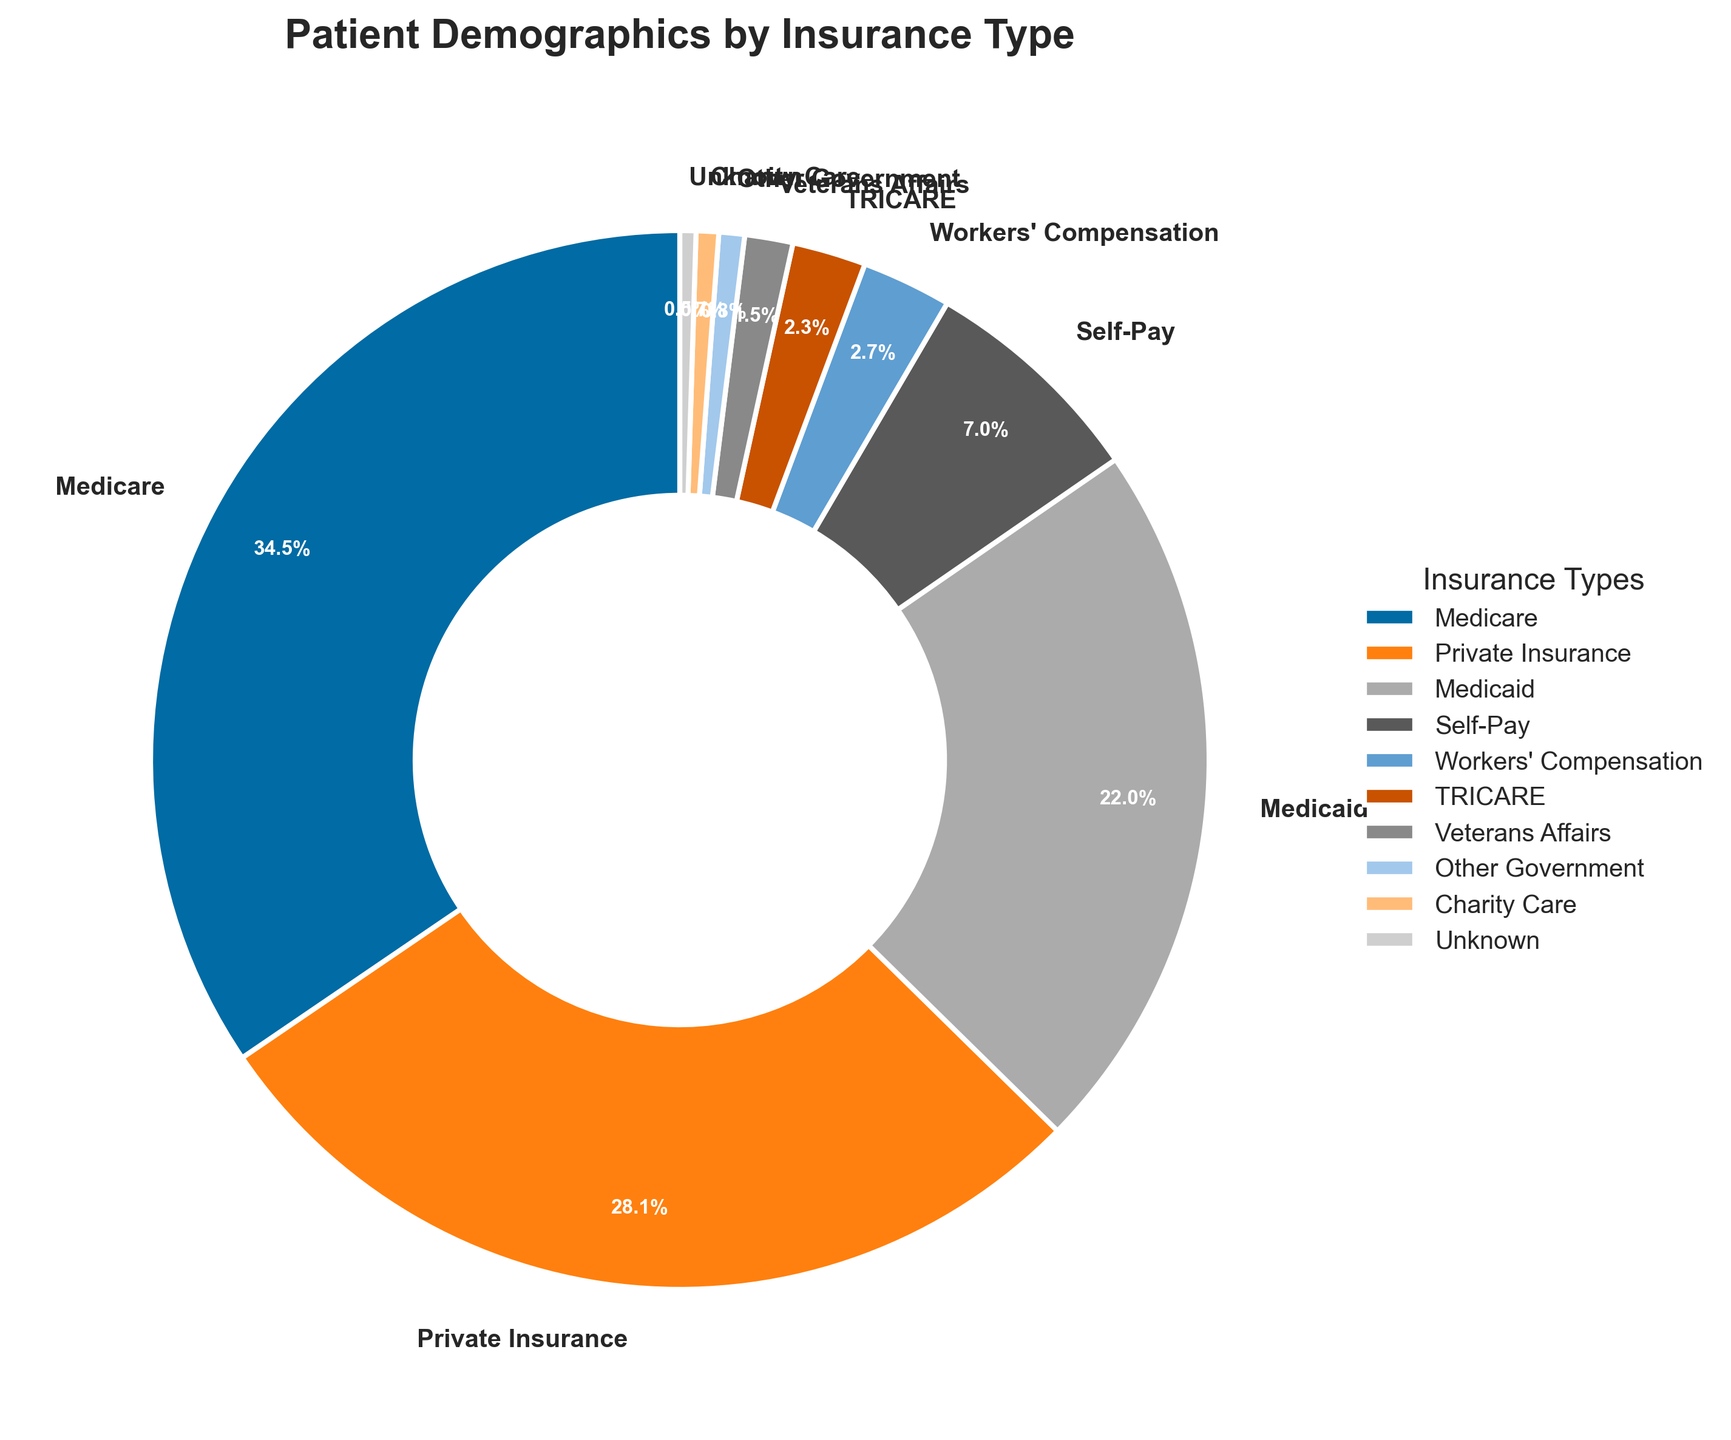Which insurance type has the highest percentage of patients? By looking at the pie chart, the largest slice represents the insurance type with the highest percentage. The label on this slice reads "Medicare" with a percentage of 35.2%.
Answer: Medicare What is the combined percentage of patients with Private Insurance and Medicaid? The slices representing Private Insurance and Medicaid have labels showing percentages of 28.7% and 22.4%, respectively. The combined percentage is 28.7 + 22.4 = 51.1%.
Answer: 51.1% How much larger is the percentage of patients with Medicare compared to patients with Medicaid? The pie chart shows Medicare at 35.2% and Medicaid at 22.4%. The difference in percentage is calculated as 35.2 - 22.4 = 12.8%.
Answer: 12.8% Which insurance type represents the smallest percentage of patients? The smallest slice on the pie chart corresponds to Charity Care with a percentage of 0.7%, as indicated by the label.
Answer: Charity Care Are there more patients with Self-Pay insurance or Workers' Compensation insurance? By comparing the sizes of the slices for Self-Pay (7.1%) and Workers' Compensation (2.8%), it's clear that Self-Pay represents a larger percentage.
Answer: Self-Pay What is the percentage difference between patients with TRICARE and Veterans Affairs insurance? The pie chart shows that TRICARE accounts for 2.3% and Veterans Affairs for 1.5%. The percentage difference is 2.3 - 1.5 = 0.8%.
Answer: 0.8% Which non-government insurance type has the highest percentage of patients? Among non-government insurance types, Private Insurance has the highest percentage of 28.7%, as seen in the pie chart.
Answer: Private Insurance What is the combined percentage of all government-related insurance types (Medicare, Medicaid, TRICARE, Veterans Affairs, and Other Government)? The percentages for government-related insurance types are: Medicare (35.2%), Medicaid (22.4%), TRICARE (2.3%), Veterans Affairs (1.5%), and Other Government (0.8%). Their combined percentage is 35.2 + 22.4 + 2.3 + 1.5 + 0.8 = 62.2%.
Answer: 62.2% 